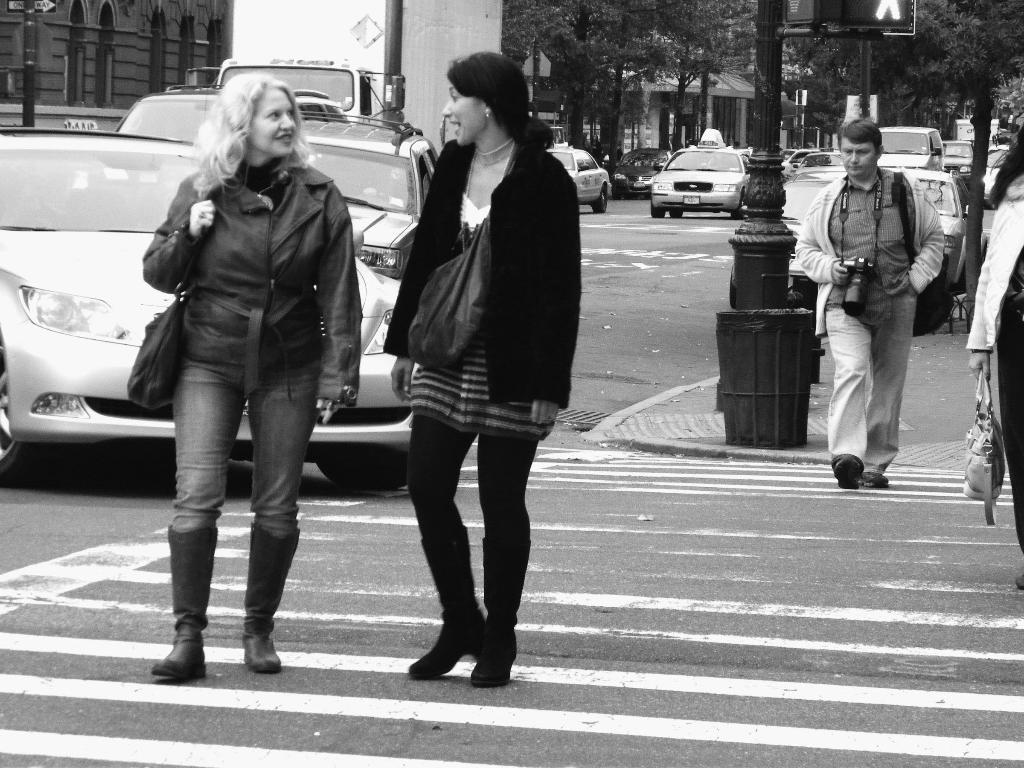What is the color scheme of the image? The image is black and white. What can be seen on the road in the image? There are vehicles on the road in the image. What type of natural elements are present in the image? Trees are present in the image. What type of man-made structures can be seen in the image? Poles and buildings are visible in the image. How many people are walking on the road in the image? There are four persons walking on the road in the image. What type of sail can be seen on the road in the image? There is no sail present on the road in the image. How much payment is being exchanged between the persons walking on the road in the image? There is no indication of any payment being exchanged between the persons walking on the road in the image. 